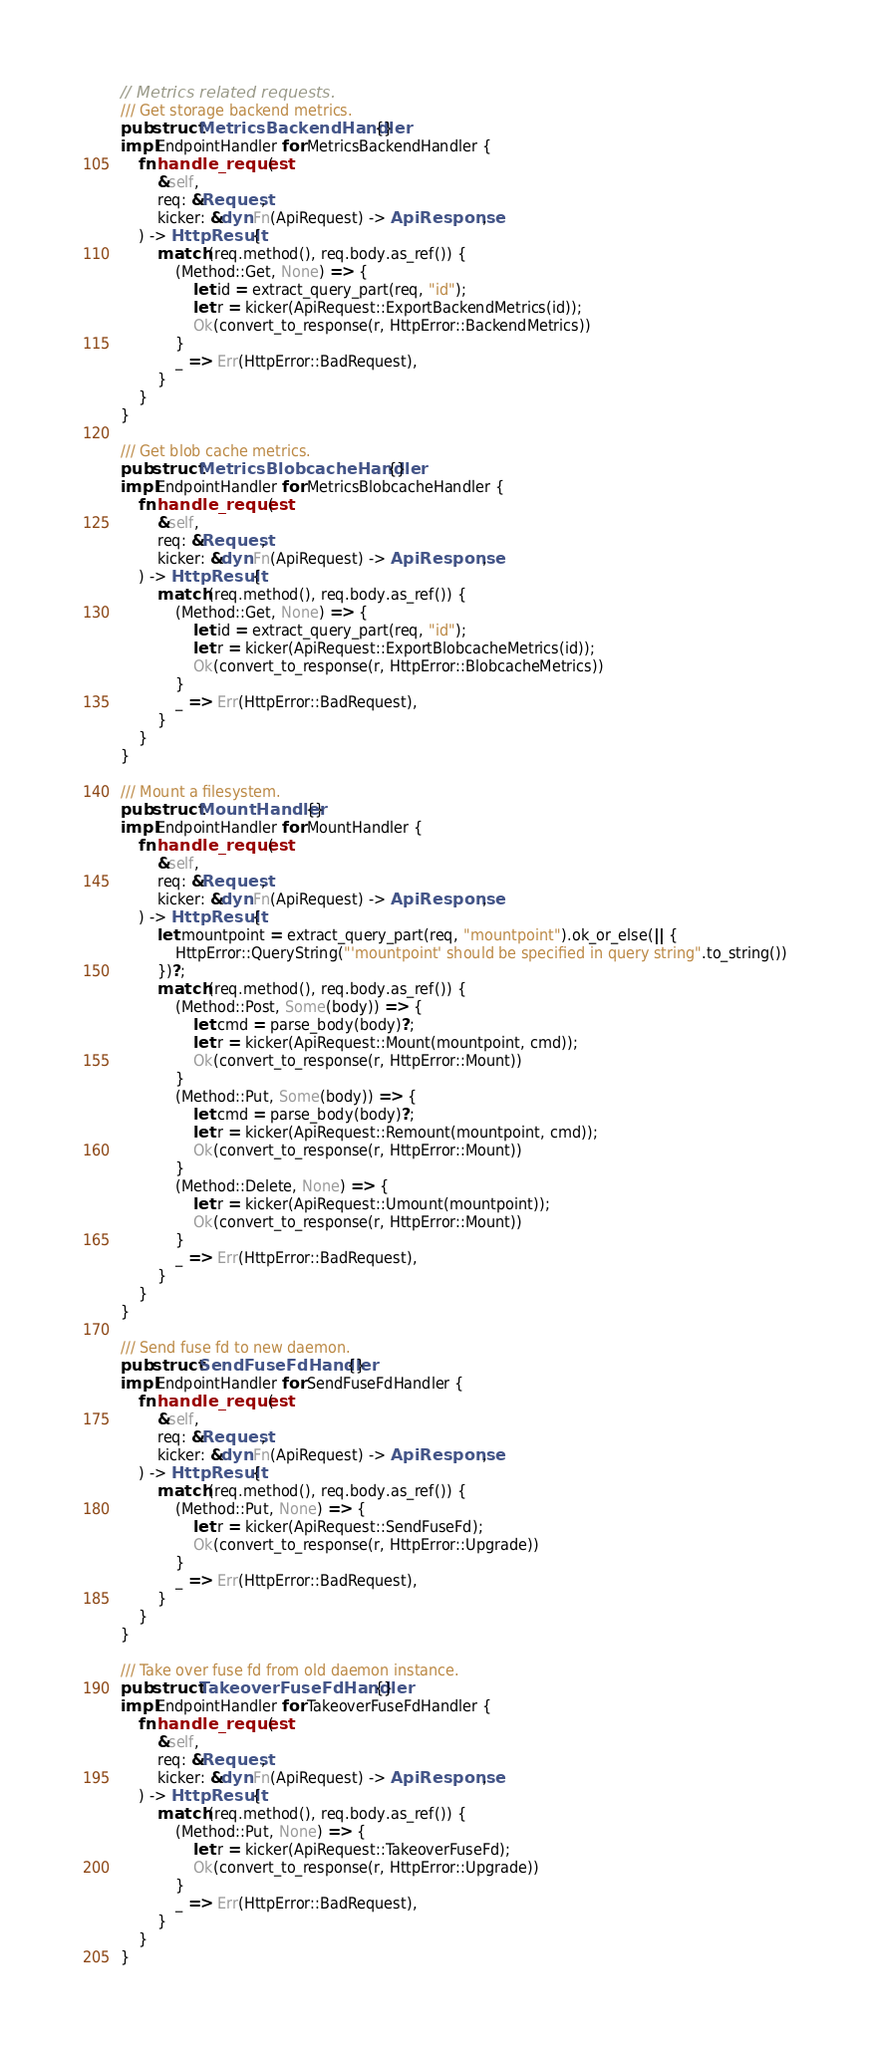<code> <loc_0><loc_0><loc_500><loc_500><_Rust_>
// Metrics related requests.
/// Get storage backend metrics.
pub struct MetricsBackendHandler {}
impl EndpointHandler for MetricsBackendHandler {
    fn handle_request(
        &self,
        req: &Request,
        kicker: &dyn Fn(ApiRequest) -> ApiResponse,
    ) -> HttpResult {
        match (req.method(), req.body.as_ref()) {
            (Method::Get, None) => {
                let id = extract_query_part(req, "id");
                let r = kicker(ApiRequest::ExportBackendMetrics(id));
                Ok(convert_to_response(r, HttpError::BackendMetrics))
            }
            _ => Err(HttpError::BadRequest),
        }
    }
}

/// Get blob cache metrics.
pub struct MetricsBlobcacheHandler {}
impl EndpointHandler for MetricsBlobcacheHandler {
    fn handle_request(
        &self,
        req: &Request,
        kicker: &dyn Fn(ApiRequest) -> ApiResponse,
    ) -> HttpResult {
        match (req.method(), req.body.as_ref()) {
            (Method::Get, None) => {
                let id = extract_query_part(req, "id");
                let r = kicker(ApiRequest::ExportBlobcacheMetrics(id));
                Ok(convert_to_response(r, HttpError::BlobcacheMetrics))
            }
            _ => Err(HttpError::BadRequest),
        }
    }
}

/// Mount a filesystem.
pub struct MountHandler {}
impl EndpointHandler for MountHandler {
    fn handle_request(
        &self,
        req: &Request,
        kicker: &dyn Fn(ApiRequest) -> ApiResponse,
    ) -> HttpResult {
        let mountpoint = extract_query_part(req, "mountpoint").ok_or_else(|| {
            HttpError::QueryString("'mountpoint' should be specified in query string".to_string())
        })?;
        match (req.method(), req.body.as_ref()) {
            (Method::Post, Some(body)) => {
                let cmd = parse_body(body)?;
                let r = kicker(ApiRequest::Mount(mountpoint, cmd));
                Ok(convert_to_response(r, HttpError::Mount))
            }
            (Method::Put, Some(body)) => {
                let cmd = parse_body(body)?;
                let r = kicker(ApiRequest::Remount(mountpoint, cmd));
                Ok(convert_to_response(r, HttpError::Mount))
            }
            (Method::Delete, None) => {
                let r = kicker(ApiRequest::Umount(mountpoint));
                Ok(convert_to_response(r, HttpError::Mount))
            }
            _ => Err(HttpError::BadRequest),
        }
    }
}

/// Send fuse fd to new daemon.
pub struct SendFuseFdHandler {}
impl EndpointHandler for SendFuseFdHandler {
    fn handle_request(
        &self,
        req: &Request,
        kicker: &dyn Fn(ApiRequest) -> ApiResponse,
    ) -> HttpResult {
        match (req.method(), req.body.as_ref()) {
            (Method::Put, None) => {
                let r = kicker(ApiRequest::SendFuseFd);
                Ok(convert_to_response(r, HttpError::Upgrade))
            }
            _ => Err(HttpError::BadRequest),
        }
    }
}

/// Take over fuse fd from old daemon instance.
pub struct TakeoverFuseFdHandler {}
impl EndpointHandler for TakeoverFuseFdHandler {
    fn handle_request(
        &self,
        req: &Request,
        kicker: &dyn Fn(ApiRequest) -> ApiResponse,
    ) -> HttpResult {
        match (req.method(), req.body.as_ref()) {
            (Method::Put, None) => {
                let r = kicker(ApiRequest::TakeoverFuseFd);
                Ok(convert_to_response(r, HttpError::Upgrade))
            }
            _ => Err(HttpError::BadRequest),
        }
    }
}
</code> 